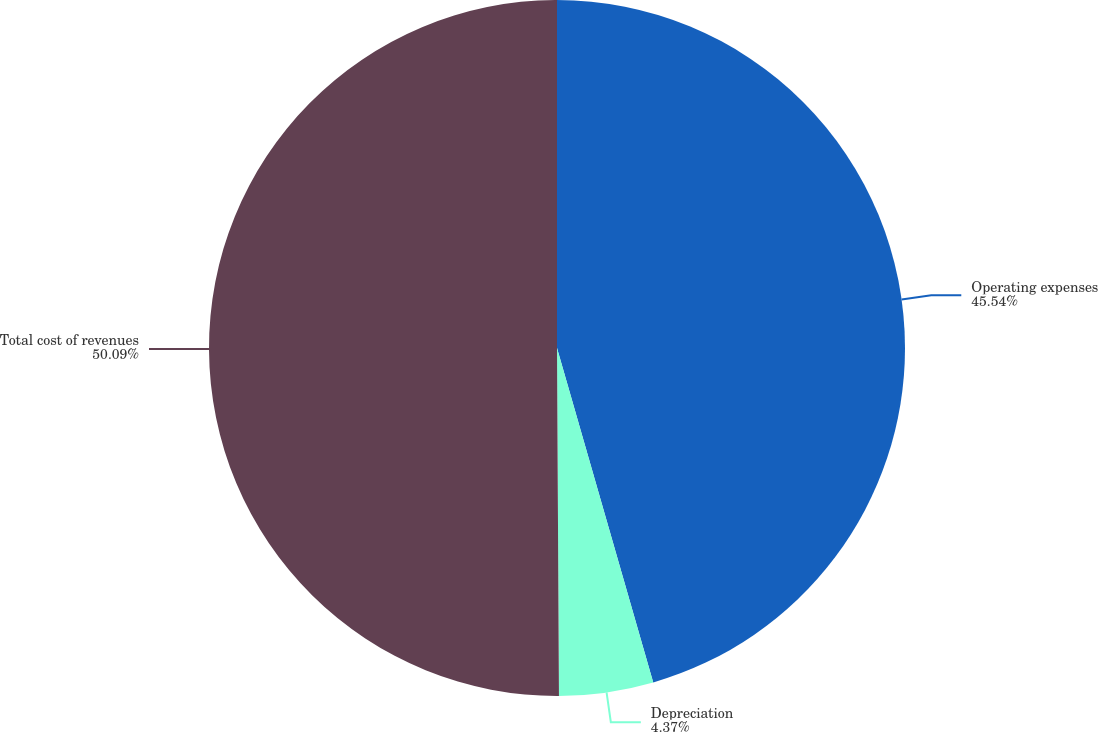<chart> <loc_0><loc_0><loc_500><loc_500><pie_chart><fcel>Operating expenses<fcel>Depreciation<fcel>Total cost of revenues<nl><fcel>45.54%<fcel>4.37%<fcel>50.09%<nl></chart> 